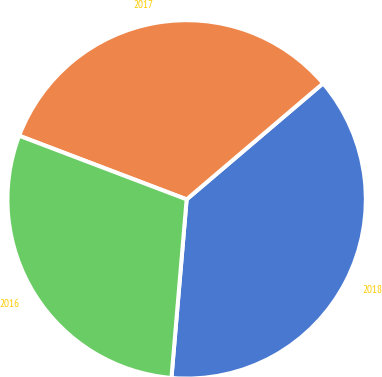Convert chart to OTSL. <chart><loc_0><loc_0><loc_500><loc_500><pie_chart><fcel>2018<fcel>2017<fcel>2016<nl><fcel>37.57%<fcel>33.0%<fcel>29.43%<nl></chart> 